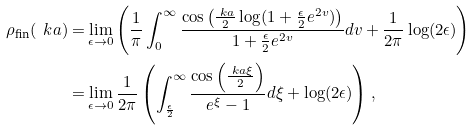<formula> <loc_0><loc_0><loc_500><loc_500>\rho _ { \text {fin} } ( \ k a ) = & \lim _ { \epsilon \rightarrow 0 } \left ( \frac { 1 } { \pi } \int _ { 0 } ^ { \infty } \frac { \cos \left ( \frac { \ k a } { 2 } \log ( 1 + \frac { \epsilon } { 2 } e ^ { 2 v } ) \right ) } { 1 + \frac { \epsilon } { 2 } e ^ { 2 v } } d v + \frac { 1 } { 2 \pi } \log ( 2 \epsilon ) \right ) \\ = & \lim _ { \epsilon \rightarrow 0 } \frac { 1 } { 2 \pi } \left ( \int _ { \frac { \epsilon } { 2 } } ^ { \infty } \frac { \cos \left ( \frac { \ k a \xi } { 2 } \right ) } { e ^ { \xi } - 1 } d \xi + \log ( 2 \epsilon ) \right ) ,</formula> 